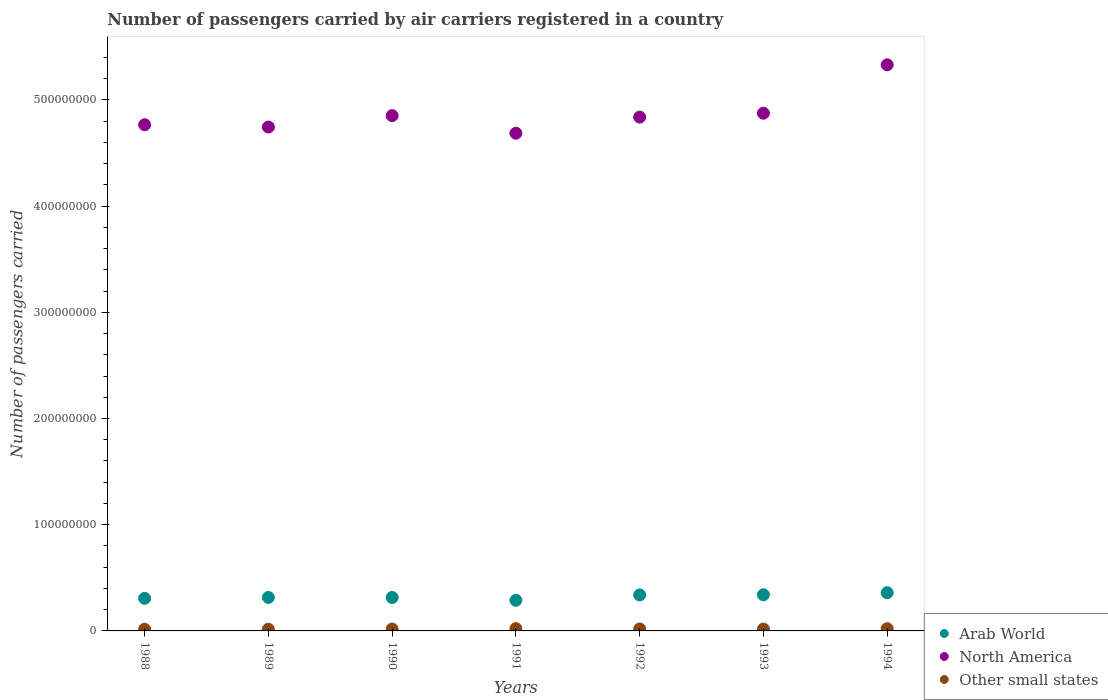Is the number of dotlines equal to the number of legend labels?
Offer a very short reply. Yes. What is the number of passengers carried by air carriers in Other small states in 1990?
Keep it short and to the point. 1.78e+06. Across all years, what is the maximum number of passengers carried by air carriers in Other small states?
Your response must be concise. 2.20e+06. Across all years, what is the minimum number of passengers carried by air carriers in Other small states?
Offer a terse response. 1.58e+06. In which year was the number of passengers carried by air carriers in Arab World maximum?
Your answer should be very brief. 1994. In which year was the number of passengers carried by air carriers in Other small states minimum?
Make the answer very short. 1988. What is the total number of passengers carried by air carriers in Other small states in the graph?
Give a very brief answer. 1.28e+07. What is the difference between the number of passengers carried by air carriers in Other small states in 1991 and that in 1993?
Your answer should be compact. 4.49e+05. What is the difference between the number of passengers carried by air carriers in Other small states in 1991 and the number of passengers carried by air carriers in North America in 1992?
Provide a short and direct response. -4.82e+08. What is the average number of passengers carried by air carriers in Arab World per year?
Ensure brevity in your answer.  3.23e+07. In the year 1992, what is the difference between the number of passengers carried by air carriers in Other small states and number of passengers carried by air carriers in Arab World?
Provide a succinct answer. -3.20e+07. What is the ratio of the number of passengers carried by air carriers in North America in 1988 to that in 1992?
Provide a short and direct response. 0.99. What is the difference between the highest and the second highest number of passengers carried by air carriers in Arab World?
Your answer should be very brief. 1.95e+06. What is the difference between the highest and the lowest number of passengers carried by air carriers in North America?
Offer a terse response. 6.44e+07. In how many years, is the number of passengers carried by air carriers in Arab World greater than the average number of passengers carried by air carriers in Arab World taken over all years?
Provide a short and direct response. 3. Is the number of passengers carried by air carriers in North America strictly greater than the number of passengers carried by air carriers in Arab World over the years?
Ensure brevity in your answer.  Yes. Is the number of passengers carried by air carriers in North America strictly less than the number of passengers carried by air carriers in Other small states over the years?
Provide a short and direct response. No. How many dotlines are there?
Keep it short and to the point. 3. Does the graph contain any zero values?
Provide a succinct answer. No. Where does the legend appear in the graph?
Keep it short and to the point. Bottom right. How many legend labels are there?
Offer a very short reply. 3. How are the legend labels stacked?
Provide a short and direct response. Vertical. What is the title of the graph?
Ensure brevity in your answer.  Number of passengers carried by air carriers registered in a country. What is the label or title of the Y-axis?
Ensure brevity in your answer.  Number of passengers carried. What is the Number of passengers carried of Arab World in 1988?
Keep it short and to the point. 3.07e+07. What is the Number of passengers carried in North America in 1988?
Keep it short and to the point. 4.77e+08. What is the Number of passengers carried in Other small states in 1988?
Provide a succinct answer. 1.58e+06. What is the Number of passengers carried of Arab World in 1989?
Make the answer very short. 3.15e+07. What is the Number of passengers carried in North America in 1989?
Give a very brief answer. 4.74e+08. What is the Number of passengers carried in Other small states in 1989?
Give a very brief answer. 1.60e+06. What is the Number of passengers carried of Arab World in 1990?
Offer a very short reply. 3.15e+07. What is the Number of passengers carried of North America in 1990?
Provide a succinct answer. 4.85e+08. What is the Number of passengers carried in Other small states in 1990?
Make the answer very short. 1.78e+06. What is the Number of passengers carried of Arab World in 1991?
Offer a terse response. 2.88e+07. What is the Number of passengers carried of North America in 1991?
Your response must be concise. 4.69e+08. What is the Number of passengers carried in Other small states in 1991?
Your answer should be compact. 2.20e+06. What is the Number of passengers carried in Arab World in 1992?
Ensure brevity in your answer.  3.39e+07. What is the Number of passengers carried in North America in 1992?
Ensure brevity in your answer.  4.84e+08. What is the Number of passengers carried in Other small states in 1992?
Give a very brief answer. 1.85e+06. What is the Number of passengers carried of Arab World in 1993?
Provide a short and direct response. 3.40e+07. What is the Number of passengers carried in North America in 1993?
Offer a terse response. 4.87e+08. What is the Number of passengers carried in Other small states in 1993?
Keep it short and to the point. 1.75e+06. What is the Number of passengers carried in Arab World in 1994?
Offer a terse response. 3.60e+07. What is the Number of passengers carried of North America in 1994?
Provide a short and direct response. 5.33e+08. What is the Number of passengers carried in Other small states in 1994?
Your answer should be compact. 2.08e+06. Across all years, what is the maximum Number of passengers carried of Arab World?
Provide a succinct answer. 3.60e+07. Across all years, what is the maximum Number of passengers carried in North America?
Your response must be concise. 5.33e+08. Across all years, what is the maximum Number of passengers carried of Other small states?
Provide a succinct answer. 2.20e+06. Across all years, what is the minimum Number of passengers carried of Arab World?
Make the answer very short. 2.88e+07. Across all years, what is the minimum Number of passengers carried in North America?
Offer a terse response. 4.69e+08. Across all years, what is the minimum Number of passengers carried in Other small states?
Keep it short and to the point. 1.58e+06. What is the total Number of passengers carried of Arab World in the graph?
Make the answer very short. 2.26e+08. What is the total Number of passengers carried in North America in the graph?
Ensure brevity in your answer.  3.41e+09. What is the total Number of passengers carried in Other small states in the graph?
Provide a succinct answer. 1.28e+07. What is the difference between the Number of passengers carried of Arab World in 1988 and that in 1989?
Offer a very short reply. -8.65e+05. What is the difference between the Number of passengers carried in North America in 1988 and that in 1989?
Your response must be concise. 2.15e+06. What is the difference between the Number of passengers carried in Other small states in 1988 and that in 1989?
Ensure brevity in your answer.  -2.64e+04. What is the difference between the Number of passengers carried of Arab World in 1988 and that in 1990?
Make the answer very short. -8.24e+05. What is the difference between the Number of passengers carried in North America in 1988 and that in 1990?
Keep it short and to the point. -8.59e+06. What is the difference between the Number of passengers carried in Other small states in 1988 and that in 1990?
Keep it short and to the point. -2.03e+05. What is the difference between the Number of passengers carried of Arab World in 1988 and that in 1991?
Ensure brevity in your answer.  1.82e+06. What is the difference between the Number of passengers carried of North America in 1988 and that in 1991?
Your answer should be compact. 7.98e+06. What is the difference between the Number of passengers carried of Other small states in 1988 and that in 1991?
Provide a succinct answer. -6.28e+05. What is the difference between the Number of passengers carried in Arab World in 1988 and that in 1992?
Your answer should be compact. -3.22e+06. What is the difference between the Number of passengers carried of North America in 1988 and that in 1992?
Your answer should be very brief. -7.20e+06. What is the difference between the Number of passengers carried in Other small states in 1988 and that in 1992?
Your answer should be compact. -2.72e+05. What is the difference between the Number of passengers carried of Arab World in 1988 and that in 1993?
Your answer should be very brief. -3.36e+06. What is the difference between the Number of passengers carried of North America in 1988 and that in 1993?
Your answer should be very brief. -1.09e+07. What is the difference between the Number of passengers carried in Other small states in 1988 and that in 1993?
Provide a succinct answer. -1.79e+05. What is the difference between the Number of passengers carried of Arab World in 1988 and that in 1994?
Ensure brevity in your answer.  -5.31e+06. What is the difference between the Number of passengers carried in North America in 1988 and that in 1994?
Offer a very short reply. -5.64e+07. What is the difference between the Number of passengers carried in Other small states in 1988 and that in 1994?
Provide a succinct answer. -5.02e+05. What is the difference between the Number of passengers carried of Arab World in 1989 and that in 1990?
Offer a very short reply. 4.11e+04. What is the difference between the Number of passengers carried of North America in 1989 and that in 1990?
Offer a terse response. -1.07e+07. What is the difference between the Number of passengers carried of Other small states in 1989 and that in 1990?
Offer a very short reply. -1.77e+05. What is the difference between the Number of passengers carried in Arab World in 1989 and that in 1991?
Make the answer very short. 2.69e+06. What is the difference between the Number of passengers carried in North America in 1989 and that in 1991?
Give a very brief answer. 5.83e+06. What is the difference between the Number of passengers carried in Other small states in 1989 and that in 1991?
Your response must be concise. -6.02e+05. What is the difference between the Number of passengers carried of Arab World in 1989 and that in 1992?
Your answer should be compact. -2.35e+06. What is the difference between the Number of passengers carried of North America in 1989 and that in 1992?
Offer a terse response. -9.35e+06. What is the difference between the Number of passengers carried of Other small states in 1989 and that in 1992?
Give a very brief answer. -2.46e+05. What is the difference between the Number of passengers carried in Arab World in 1989 and that in 1993?
Provide a short and direct response. -2.49e+06. What is the difference between the Number of passengers carried in North America in 1989 and that in 1993?
Provide a short and direct response. -1.30e+07. What is the difference between the Number of passengers carried in Other small states in 1989 and that in 1993?
Offer a very short reply. -1.53e+05. What is the difference between the Number of passengers carried of Arab World in 1989 and that in 1994?
Give a very brief answer. -4.44e+06. What is the difference between the Number of passengers carried in North America in 1989 and that in 1994?
Provide a succinct answer. -5.86e+07. What is the difference between the Number of passengers carried of Other small states in 1989 and that in 1994?
Make the answer very short. -4.76e+05. What is the difference between the Number of passengers carried of Arab World in 1990 and that in 1991?
Ensure brevity in your answer.  2.65e+06. What is the difference between the Number of passengers carried in North America in 1990 and that in 1991?
Keep it short and to the point. 1.66e+07. What is the difference between the Number of passengers carried of Other small states in 1990 and that in 1991?
Offer a terse response. -4.25e+05. What is the difference between the Number of passengers carried in Arab World in 1990 and that in 1992?
Give a very brief answer. -2.39e+06. What is the difference between the Number of passengers carried of North America in 1990 and that in 1992?
Your answer should be compact. 1.39e+06. What is the difference between the Number of passengers carried in Other small states in 1990 and that in 1992?
Ensure brevity in your answer.  -6.94e+04. What is the difference between the Number of passengers carried of Arab World in 1990 and that in 1993?
Provide a succinct answer. -2.53e+06. What is the difference between the Number of passengers carried of North America in 1990 and that in 1993?
Your answer should be very brief. -2.27e+06. What is the difference between the Number of passengers carried in Other small states in 1990 and that in 1993?
Your answer should be compact. 2.36e+04. What is the difference between the Number of passengers carried in Arab World in 1990 and that in 1994?
Your answer should be very brief. -4.48e+06. What is the difference between the Number of passengers carried of North America in 1990 and that in 1994?
Provide a succinct answer. -4.79e+07. What is the difference between the Number of passengers carried in Other small states in 1990 and that in 1994?
Your answer should be compact. -2.99e+05. What is the difference between the Number of passengers carried of Arab World in 1991 and that in 1992?
Your response must be concise. -5.04e+06. What is the difference between the Number of passengers carried of North America in 1991 and that in 1992?
Offer a terse response. -1.52e+07. What is the difference between the Number of passengers carried in Other small states in 1991 and that in 1992?
Your answer should be very brief. 3.56e+05. What is the difference between the Number of passengers carried of Arab World in 1991 and that in 1993?
Offer a terse response. -5.18e+06. What is the difference between the Number of passengers carried of North America in 1991 and that in 1993?
Keep it short and to the point. -1.88e+07. What is the difference between the Number of passengers carried in Other small states in 1991 and that in 1993?
Your answer should be very brief. 4.49e+05. What is the difference between the Number of passengers carried in Arab World in 1991 and that in 1994?
Offer a terse response. -7.13e+06. What is the difference between the Number of passengers carried in North America in 1991 and that in 1994?
Your answer should be compact. -6.44e+07. What is the difference between the Number of passengers carried of Other small states in 1991 and that in 1994?
Your answer should be compact. 1.26e+05. What is the difference between the Number of passengers carried of Arab World in 1992 and that in 1993?
Offer a very short reply. -1.40e+05. What is the difference between the Number of passengers carried in North America in 1992 and that in 1993?
Keep it short and to the point. -3.66e+06. What is the difference between the Number of passengers carried of Other small states in 1992 and that in 1993?
Give a very brief answer. 9.30e+04. What is the difference between the Number of passengers carried in Arab World in 1992 and that in 1994?
Keep it short and to the point. -2.09e+06. What is the difference between the Number of passengers carried in North America in 1992 and that in 1994?
Your response must be concise. -4.92e+07. What is the difference between the Number of passengers carried of Other small states in 1992 and that in 1994?
Offer a very short reply. -2.30e+05. What is the difference between the Number of passengers carried of Arab World in 1993 and that in 1994?
Offer a terse response. -1.95e+06. What is the difference between the Number of passengers carried in North America in 1993 and that in 1994?
Your answer should be compact. -4.56e+07. What is the difference between the Number of passengers carried of Other small states in 1993 and that in 1994?
Provide a short and direct response. -3.23e+05. What is the difference between the Number of passengers carried of Arab World in 1988 and the Number of passengers carried of North America in 1989?
Give a very brief answer. -4.44e+08. What is the difference between the Number of passengers carried of Arab World in 1988 and the Number of passengers carried of Other small states in 1989?
Your answer should be very brief. 2.91e+07. What is the difference between the Number of passengers carried in North America in 1988 and the Number of passengers carried in Other small states in 1989?
Your answer should be compact. 4.75e+08. What is the difference between the Number of passengers carried of Arab World in 1988 and the Number of passengers carried of North America in 1990?
Your response must be concise. -4.55e+08. What is the difference between the Number of passengers carried in Arab World in 1988 and the Number of passengers carried in Other small states in 1990?
Give a very brief answer. 2.89e+07. What is the difference between the Number of passengers carried of North America in 1988 and the Number of passengers carried of Other small states in 1990?
Your answer should be very brief. 4.75e+08. What is the difference between the Number of passengers carried in Arab World in 1988 and the Number of passengers carried in North America in 1991?
Keep it short and to the point. -4.38e+08. What is the difference between the Number of passengers carried of Arab World in 1988 and the Number of passengers carried of Other small states in 1991?
Your answer should be very brief. 2.85e+07. What is the difference between the Number of passengers carried in North America in 1988 and the Number of passengers carried in Other small states in 1991?
Offer a terse response. 4.74e+08. What is the difference between the Number of passengers carried in Arab World in 1988 and the Number of passengers carried in North America in 1992?
Give a very brief answer. -4.53e+08. What is the difference between the Number of passengers carried in Arab World in 1988 and the Number of passengers carried in Other small states in 1992?
Your answer should be compact. 2.88e+07. What is the difference between the Number of passengers carried of North America in 1988 and the Number of passengers carried of Other small states in 1992?
Keep it short and to the point. 4.75e+08. What is the difference between the Number of passengers carried in Arab World in 1988 and the Number of passengers carried in North America in 1993?
Provide a short and direct response. -4.57e+08. What is the difference between the Number of passengers carried of Arab World in 1988 and the Number of passengers carried of Other small states in 1993?
Provide a short and direct response. 2.89e+07. What is the difference between the Number of passengers carried of North America in 1988 and the Number of passengers carried of Other small states in 1993?
Your answer should be compact. 4.75e+08. What is the difference between the Number of passengers carried of Arab World in 1988 and the Number of passengers carried of North America in 1994?
Offer a very short reply. -5.02e+08. What is the difference between the Number of passengers carried of Arab World in 1988 and the Number of passengers carried of Other small states in 1994?
Your response must be concise. 2.86e+07. What is the difference between the Number of passengers carried of North America in 1988 and the Number of passengers carried of Other small states in 1994?
Provide a succinct answer. 4.75e+08. What is the difference between the Number of passengers carried in Arab World in 1989 and the Number of passengers carried in North America in 1990?
Your response must be concise. -4.54e+08. What is the difference between the Number of passengers carried of Arab World in 1989 and the Number of passengers carried of Other small states in 1990?
Provide a succinct answer. 2.97e+07. What is the difference between the Number of passengers carried of North America in 1989 and the Number of passengers carried of Other small states in 1990?
Make the answer very short. 4.73e+08. What is the difference between the Number of passengers carried in Arab World in 1989 and the Number of passengers carried in North America in 1991?
Your response must be concise. -4.37e+08. What is the difference between the Number of passengers carried in Arab World in 1989 and the Number of passengers carried in Other small states in 1991?
Make the answer very short. 2.93e+07. What is the difference between the Number of passengers carried in North America in 1989 and the Number of passengers carried in Other small states in 1991?
Your answer should be compact. 4.72e+08. What is the difference between the Number of passengers carried of Arab World in 1989 and the Number of passengers carried of North America in 1992?
Your response must be concise. -4.52e+08. What is the difference between the Number of passengers carried in Arab World in 1989 and the Number of passengers carried in Other small states in 1992?
Make the answer very short. 2.97e+07. What is the difference between the Number of passengers carried in North America in 1989 and the Number of passengers carried in Other small states in 1992?
Offer a terse response. 4.73e+08. What is the difference between the Number of passengers carried in Arab World in 1989 and the Number of passengers carried in North America in 1993?
Your answer should be very brief. -4.56e+08. What is the difference between the Number of passengers carried of Arab World in 1989 and the Number of passengers carried of Other small states in 1993?
Your answer should be very brief. 2.98e+07. What is the difference between the Number of passengers carried of North America in 1989 and the Number of passengers carried of Other small states in 1993?
Your answer should be compact. 4.73e+08. What is the difference between the Number of passengers carried of Arab World in 1989 and the Number of passengers carried of North America in 1994?
Provide a short and direct response. -5.02e+08. What is the difference between the Number of passengers carried in Arab World in 1989 and the Number of passengers carried in Other small states in 1994?
Offer a very short reply. 2.94e+07. What is the difference between the Number of passengers carried in North America in 1989 and the Number of passengers carried in Other small states in 1994?
Give a very brief answer. 4.72e+08. What is the difference between the Number of passengers carried in Arab World in 1990 and the Number of passengers carried in North America in 1991?
Provide a succinct answer. -4.37e+08. What is the difference between the Number of passengers carried of Arab World in 1990 and the Number of passengers carried of Other small states in 1991?
Keep it short and to the point. 2.93e+07. What is the difference between the Number of passengers carried of North America in 1990 and the Number of passengers carried of Other small states in 1991?
Offer a very short reply. 4.83e+08. What is the difference between the Number of passengers carried in Arab World in 1990 and the Number of passengers carried in North America in 1992?
Ensure brevity in your answer.  -4.52e+08. What is the difference between the Number of passengers carried in Arab World in 1990 and the Number of passengers carried in Other small states in 1992?
Provide a succinct answer. 2.96e+07. What is the difference between the Number of passengers carried of North America in 1990 and the Number of passengers carried of Other small states in 1992?
Give a very brief answer. 4.83e+08. What is the difference between the Number of passengers carried in Arab World in 1990 and the Number of passengers carried in North America in 1993?
Make the answer very short. -4.56e+08. What is the difference between the Number of passengers carried in Arab World in 1990 and the Number of passengers carried in Other small states in 1993?
Your answer should be very brief. 2.97e+07. What is the difference between the Number of passengers carried in North America in 1990 and the Number of passengers carried in Other small states in 1993?
Give a very brief answer. 4.83e+08. What is the difference between the Number of passengers carried of Arab World in 1990 and the Number of passengers carried of North America in 1994?
Your answer should be very brief. -5.02e+08. What is the difference between the Number of passengers carried of Arab World in 1990 and the Number of passengers carried of Other small states in 1994?
Your answer should be very brief. 2.94e+07. What is the difference between the Number of passengers carried of North America in 1990 and the Number of passengers carried of Other small states in 1994?
Ensure brevity in your answer.  4.83e+08. What is the difference between the Number of passengers carried of Arab World in 1991 and the Number of passengers carried of North America in 1992?
Offer a terse response. -4.55e+08. What is the difference between the Number of passengers carried in Arab World in 1991 and the Number of passengers carried in Other small states in 1992?
Keep it short and to the point. 2.70e+07. What is the difference between the Number of passengers carried of North America in 1991 and the Number of passengers carried of Other small states in 1992?
Keep it short and to the point. 4.67e+08. What is the difference between the Number of passengers carried of Arab World in 1991 and the Number of passengers carried of North America in 1993?
Provide a short and direct response. -4.59e+08. What is the difference between the Number of passengers carried of Arab World in 1991 and the Number of passengers carried of Other small states in 1993?
Offer a terse response. 2.71e+07. What is the difference between the Number of passengers carried of North America in 1991 and the Number of passengers carried of Other small states in 1993?
Your answer should be compact. 4.67e+08. What is the difference between the Number of passengers carried of Arab World in 1991 and the Number of passengers carried of North America in 1994?
Your answer should be compact. -5.04e+08. What is the difference between the Number of passengers carried of Arab World in 1991 and the Number of passengers carried of Other small states in 1994?
Your answer should be very brief. 2.68e+07. What is the difference between the Number of passengers carried in North America in 1991 and the Number of passengers carried in Other small states in 1994?
Provide a short and direct response. 4.67e+08. What is the difference between the Number of passengers carried in Arab World in 1992 and the Number of passengers carried in North America in 1993?
Make the answer very short. -4.54e+08. What is the difference between the Number of passengers carried of Arab World in 1992 and the Number of passengers carried of Other small states in 1993?
Offer a terse response. 3.21e+07. What is the difference between the Number of passengers carried in North America in 1992 and the Number of passengers carried in Other small states in 1993?
Ensure brevity in your answer.  4.82e+08. What is the difference between the Number of passengers carried of Arab World in 1992 and the Number of passengers carried of North America in 1994?
Ensure brevity in your answer.  -4.99e+08. What is the difference between the Number of passengers carried of Arab World in 1992 and the Number of passengers carried of Other small states in 1994?
Offer a very short reply. 3.18e+07. What is the difference between the Number of passengers carried in North America in 1992 and the Number of passengers carried in Other small states in 1994?
Keep it short and to the point. 4.82e+08. What is the difference between the Number of passengers carried of Arab World in 1993 and the Number of passengers carried of North America in 1994?
Provide a short and direct response. -4.99e+08. What is the difference between the Number of passengers carried of Arab World in 1993 and the Number of passengers carried of Other small states in 1994?
Your response must be concise. 3.19e+07. What is the difference between the Number of passengers carried in North America in 1993 and the Number of passengers carried in Other small states in 1994?
Your answer should be very brief. 4.85e+08. What is the average Number of passengers carried of Arab World per year?
Your answer should be very brief. 3.23e+07. What is the average Number of passengers carried in North America per year?
Provide a short and direct response. 4.87e+08. What is the average Number of passengers carried of Other small states per year?
Provide a succinct answer. 1.83e+06. In the year 1988, what is the difference between the Number of passengers carried of Arab World and Number of passengers carried of North America?
Offer a terse response. -4.46e+08. In the year 1988, what is the difference between the Number of passengers carried of Arab World and Number of passengers carried of Other small states?
Offer a terse response. 2.91e+07. In the year 1988, what is the difference between the Number of passengers carried of North America and Number of passengers carried of Other small states?
Provide a succinct answer. 4.75e+08. In the year 1989, what is the difference between the Number of passengers carried in Arab World and Number of passengers carried in North America?
Make the answer very short. -4.43e+08. In the year 1989, what is the difference between the Number of passengers carried in Arab World and Number of passengers carried in Other small states?
Your answer should be very brief. 2.99e+07. In the year 1989, what is the difference between the Number of passengers carried in North America and Number of passengers carried in Other small states?
Make the answer very short. 4.73e+08. In the year 1990, what is the difference between the Number of passengers carried in Arab World and Number of passengers carried in North America?
Provide a succinct answer. -4.54e+08. In the year 1990, what is the difference between the Number of passengers carried in Arab World and Number of passengers carried in Other small states?
Offer a very short reply. 2.97e+07. In the year 1990, what is the difference between the Number of passengers carried of North America and Number of passengers carried of Other small states?
Offer a very short reply. 4.83e+08. In the year 1991, what is the difference between the Number of passengers carried in Arab World and Number of passengers carried in North America?
Provide a short and direct response. -4.40e+08. In the year 1991, what is the difference between the Number of passengers carried in Arab World and Number of passengers carried in Other small states?
Offer a very short reply. 2.66e+07. In the year 1991, what is the difference between the Number of passengers carried in North America and Number of passengers carried in Other small states?
Make the answer very short. 4.66e+08. In the year 1992, what is the difference between the Number of passengers carried of Arab World and Number of passengers carried of North America?
Make the answer very short. -4.50e+08. In the year 1992, what is the difference between the Number of passengers carried in Arab World and Number of passengers carried in Other small states?
Provide a short and direct response. 3.20e+07. In the year 1992, what is the difference between the Number of passengers carried in North America and Number of passengers carried in Other small states?
Make the answer very short. 4.82e+08. In the year 1993, what is the difference between the Number of passengers carried in Arab World and Number of passengers carried in North America?
Your answer should be very brief. -4.53e+08. In the year 1993, what is the difference between the Number of passengers carried of Arab World and Number of passengers carried of Other small states?
Provide a short and direct response. 3.23e+07. In the year 1993, what is the difference between the Number of passengers carried in North America and Number of passengers carried in Other small states?
Your response must be concise. 4.86e+08. In the year 1994, what is the difference between the Number of passengers carried in Arab World and Number of passengers carried in North America?
Keep it short and to the point. -4.97e+08. In the year 1994, what is the difference between the Number of passengers carried of Arab World and Number of passengers carried of Other small states?
Offer a terse response. 3.39e+07. In the year 1994, what is the difference between the Number of passengers carried in North America and Number of passengers carried in Other small states?
Offer a terse response. 5.31e+08. What is the ratio of the Number of passengers carried of Arab World in 1988 to that in 1989?
Provide a succinct answer. 0.97. What is the ratio of the Number of passengers carried in North America in 1988 to that in 1989?
Keep it short and to the point. 1. What is the ratio of the Number of passengers carried of Other small states in 1988 to that in 1989?
Give a very brief answer. 0.98. What is the ratio of the Number of passengers carried in Arab World in 1988 to that in 1990?
Ensure brevity in your answer.  0.97. What is the ratio of the Number of passengers carried of North America in 1988 to that in 1990?
Provide a succinct answer. 0.98. What is the ratio of the Number of passengers carried of Other small states in 1988 to that in 1990?
Provide a succinct answer. 0.89. What is the ratio of the Number of passengers carried of Arab World in 1988 to that in 1991?
Keep it short and to the point. 1.06. What is the ratio of the Number of passengers carried of Other small states in 1988 to that in 1991?
Give a very brief answer. 0.71. What is the ratio of the Number of passengers carried of Arab World in 1988 to that in 1992?
Keep it short and to the point. 0.91. What is the ratio of the Number of passengers carried of North America in 1988 to that in 1992?
Your answer should be very brief. 0.99. What is the ratio of the Number of passengers carried of Other small states in 1988 to that in 1992?
Your answer should be very brief. 0.85. What is the ratio of the Number of passengers carried of Arab World in 1988 to that in 1993?
Your answer should be very brief. 0.9. What is the ratio of the Number of passengers carried in North America in 1988 to that in 1993?
Ensure brevity in your answer.  0.98. What is the ratio of the Number of passengers carried in Other small states in 1988 to that in 1993?
Give a very brief answer. 0.9. What is the ratio of the Number of passengers carried of Arab World in 1988 to that in 1994?
Ensure brevity in your answer.  0.85. What is the ratio of the Number of passengers carried in North America in 1988 to that in 1994?
Offer a terse response. 0.89. What is the ratio of the Number of passengers carried of Other small states in 1988 to that in 1994?
Ensure brevity in your answer.  0.76. What is the ratio of the Number of passengers carried in North America in 1989 to that in 1990?
Provide a short and direct response. 0.98. What is the ratio of the Number of passengers carried in Other small states in 1989 to that in 1990?
Provide a short and direct response. 0.9. What is the ratio of the Number of passengers carried in Arab World in 1989 to that in 1991?
Make the answer very short. 1.09. What is the ratio of the Number of passengers carried of North America in 1989 to that in 1991?
Your response must be concise. 1.01. What is the ratio of the Number of passengers carried in Other small states in 1989 to that in 1991?
Your response must be concise. 0.73. What is the ratio of the Number of passengers carried in Arab World in 1989 to that in 1992?
Give a very brief answer. 0.93. What is the ratio of the Number of passengers carried of North America in 1989 to that in 1992?
Ensure brevity in your answer.  0.98. What is the ratio of the Number of passengers carried in Other small states in 1989 to that in 1992?
Make the answer very short. 0.87. What is the ratio of the Number of passengers carried of Arab World in 1989 to that in 1993?
Your answer should be compact. 0.93. What is the ratio of the Number of passengers carried of North America in 1989 to that in 1993?
Your response must be concise. 0.97. What is the ratio of the Number of passengers carried in Other small states in 1989 to that in 1993?
Your response must be concise. 0.91. What is the ratio of the Number of passengers carried of Arab World in 1989 to that in 1994?
Make the answer very short. 0.88. What is the ratio of the Number of passengers carried of North America in 1989 to that in 1994?
Keep it short and to the point. 0.89. What is the ratio of the Number of passengers carried of Other small states in 1989 to that in 1994?
Your answer should be compact. 0.77. What is the ratio of the Number of passengers carried in Arab World in 1990 to that in 1991?
Provide a short and direct response. 1.09. What is the ratio of the Number of passengers carried in North America in 1990 to that in 1991?
Your response must be concise. 1.04. What is the ratio of the Number of passengers carried in Other small states in 1990 to that in 1991?
Ensure brevity in your answer.  0.81. What is the ratio of the Number of passengers carried of Arab World in 1990 to that in 1992?
Keep it short and to the point. 0.93. What is the ratio of the Number of passengers carried in Other small states in 1990 to that in 1992?
Your answer should be very brief. 0.96. What is the ratio of the Number of passengers carried in Arab World in 1990 to that in 1993?
Ensure brevity in your answer.  0.93. What is the ratio of the Number of passengers carried in North America in 1990 to that in 1993?
Offer a terse response. 1. What is the ratio of the Number of passengers carried of Other small states in 1990 to that in 1993?
Provide a succinct answer. 1.01. What is the ratio of the Number of passengers carried in Arab World in 1990 to that in 1994?
Offer a very short reply. 0.88. What is the ratio of the Number of passengers carried of North America in 1990 to that in 1994?
Provide a short and direct response. 0.91. What is the ratio of the Number of passengers carried of Other small states in 1990 to that in 1994?
Your answer should be compact. 0.86. What is the ratio of the Number of passengers carried of Arab World in 1991 to that in 1992?
Give a very brief answer. 0.85. What is the ratio of the Number of passengers carried of North America in 1991 to that in 1992?
Provide a short and direct response. 0.97. What is the ratio of the Number of passengers carried of Other small states in 1991 to that in 1992?
Ensure brevity in your answer.  1.19. What is the ratio of the Number of passengers carried of Arab World in 1991 to that in 1993?
Your answer should be very brief. 0.85. What is the ratio of the Number of passengers carried in North America in 1991 to that in 1993?
Your answer should be very brief. 0.96. What is the ratio of the Number of passengers carried of Other small states in 1991 to that in 1993?
Make the answer very short. 1.26. What is the ratio of the Number of passengers carried in Arab World in 1991 to that in 1994?
Keep it short and to the point. 0.8. What is the ratio of the Number of passengers carried in North America in 1991 to that in 1994?
Offer a very short reply. 0.88. What is the ratio of the Number of passengers carried of Other small states in 1991 to that in 1994?
Provide a succinct answer. 1.06. What is the ratio of the Number of passengers carried of Other small states in 1992 to that in 1993?
Offer a terse response. 1.05. What is the ratio of the Number of passengers carried in Arab World in 1992 to that in 1994?
Ensure brevity in your answer.  0.94. What is the ratio of the Number of passengers carried in North America in 1992 to that in 1994?
Provide a short and direct response. 0.91. What is the ratio of the Number of passengers carried in Other small states in 1992 to that in 1994?
Keep it short and to the point. 0.89. What is the ratio of the Number of passengers carried of Arab World in 1993 to that in 1994?
Keep it short and to the point. 0.95. What is the ratio of the Number of passengers carried of North America in 1993 to that in 1994?
Your response must be concise. 0.91. What is the ratio of the Number of passengers carried in Other small states in 1993 to that in 1994?
Offer a terse response. 0.84. What is the difference between the highest and the second highest Number of passengers carried in Arab World?
Provide a succinct answer. 1.95e+06. What is the difference between the highest and the second highest Number of passengers carried of North America?
Give a very brief answer. 4.56e+07. What is the difference between the highest and the second highest Number of passengers carried in Other small states?
Make the answer very short. 1.26e+05. What is the difference between the highest and the lowest Number of passengers carried of Arab World?
Your answer should be very brief. 7.13e+06. What is the difference between the highest and the lowest Number of passengers carried of North America?
Your answer should be very brief. 6.44e+07. What is the difference between the highest and the lowest Number of passengers carried of Other small states?
Keep it short and to the point. 6.28e+05. 